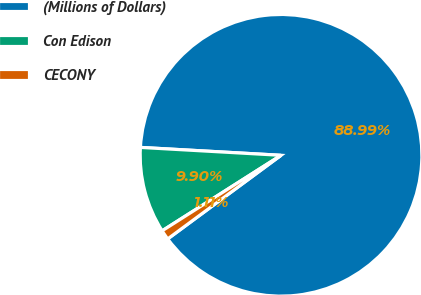<chart> <loc_0><loc_0><loc_500><loc_500><pie_chart><fcel>(Millions of Dollars)<fcel>Con Edison<fcel>CECONY<nl><fcel>89.0%<fcel>9.9%<fcel>1.11%<nl></chart> 